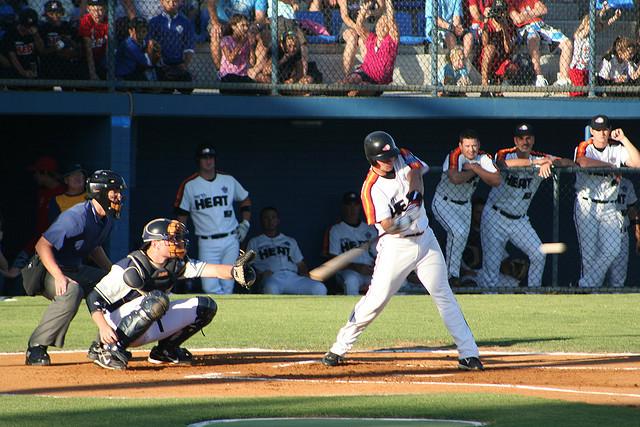How many players are on the fence?
Quick response, please. 3. What do the white uniforms say on the front?
Be succinct. Heat. Is the batter swinging the bat?
Quick response, please. Yes. 